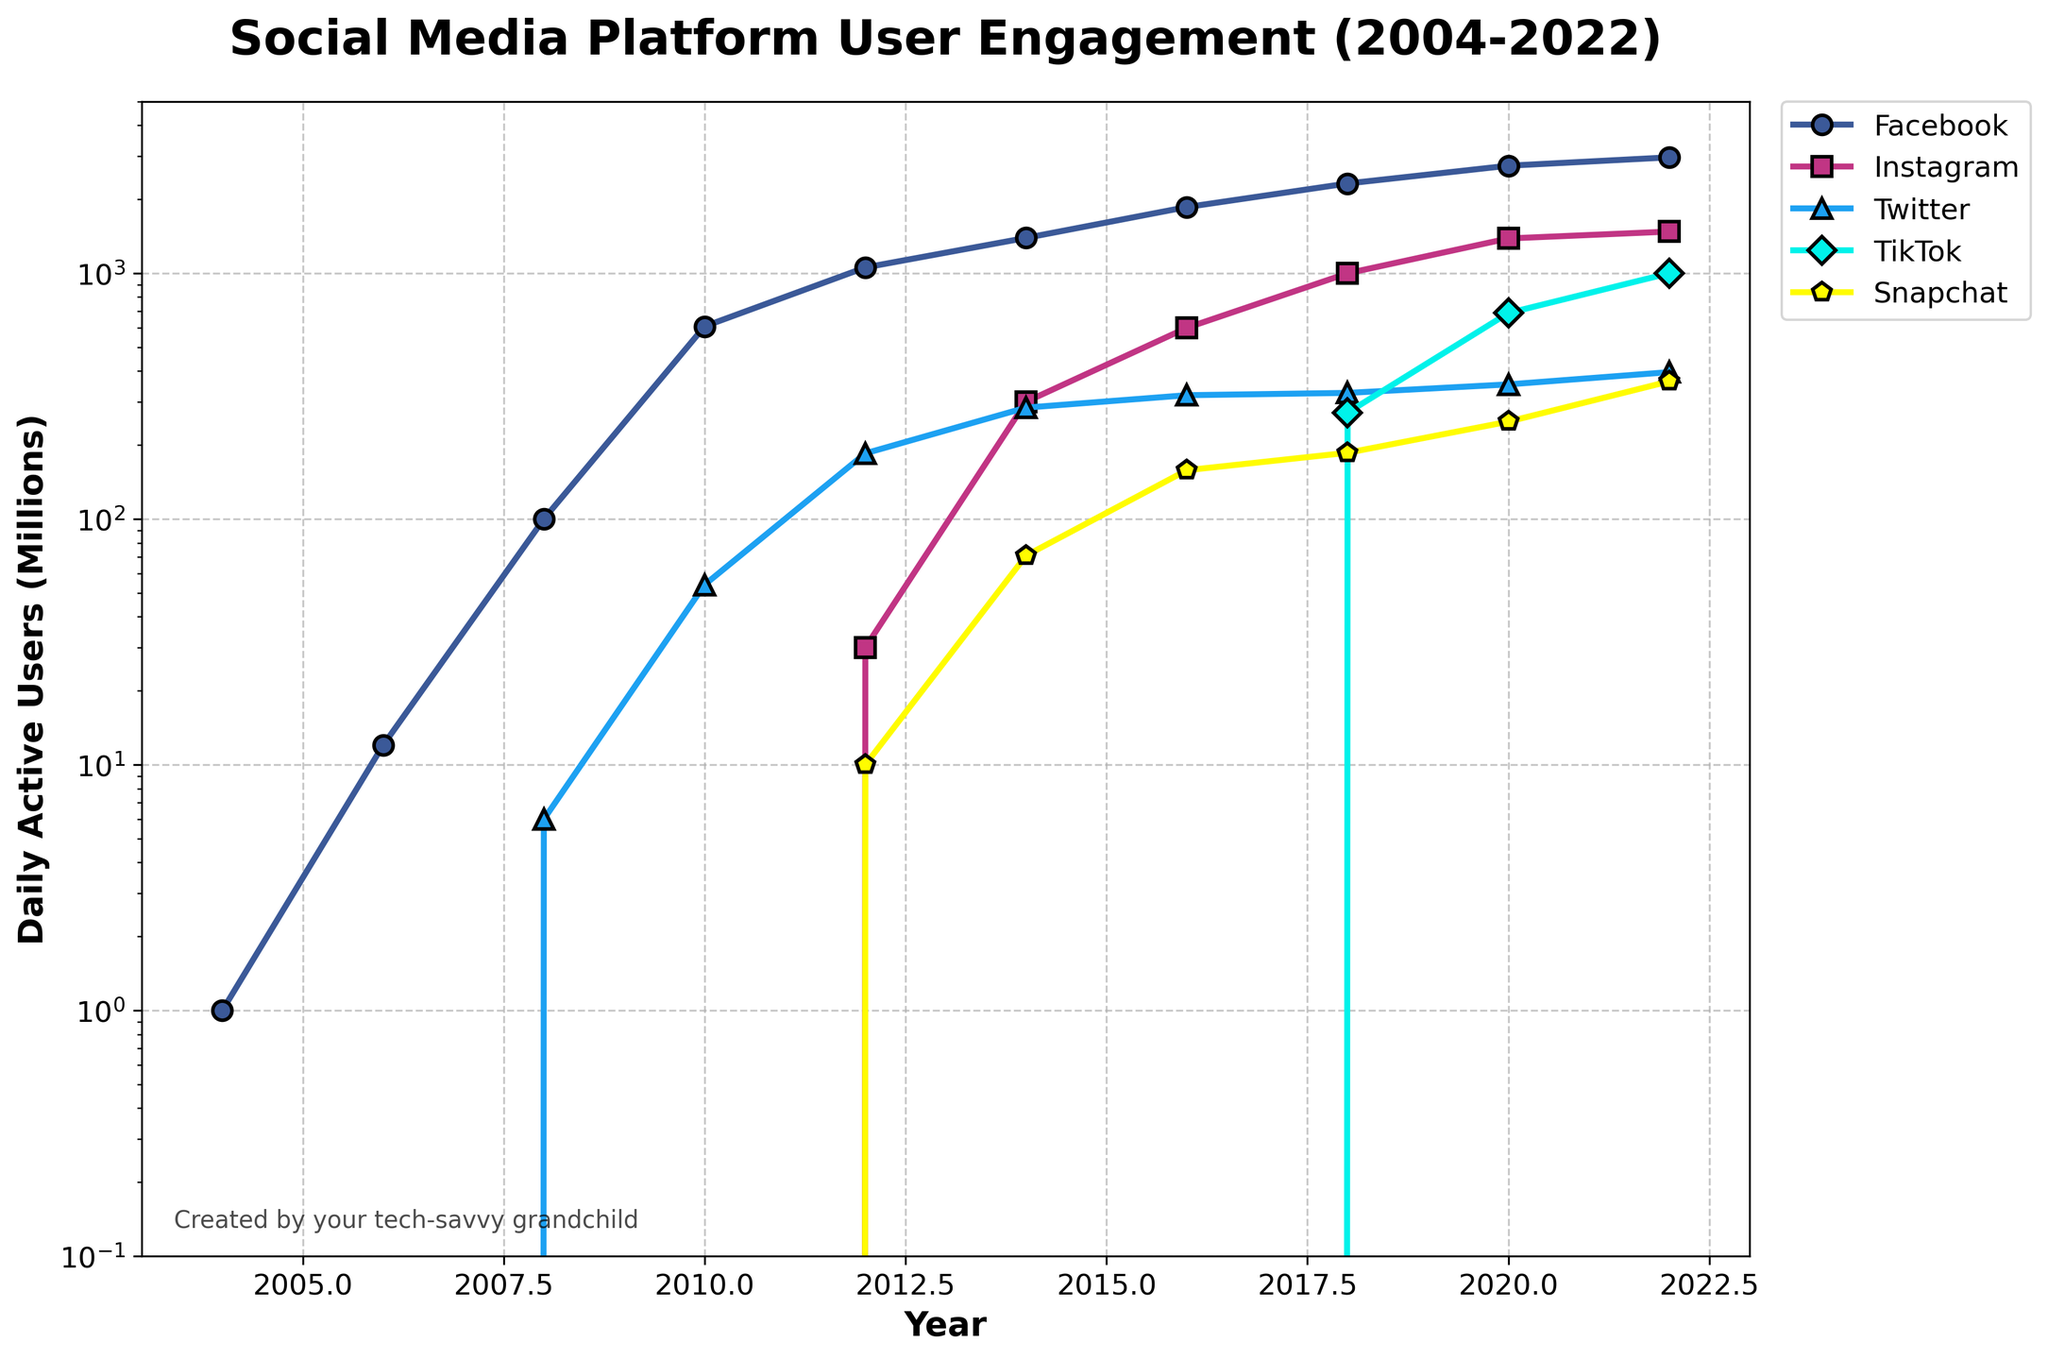What trend do you notice in Facebook's user engagement from 2004 to 2022? From 2004 to 2022, Facebook's user engagement has steadily increased, starting from 1 million daily active users in 2004 and reaching approximately 2,963 million daily active users in 2022. This shows a consistent growth in user engagement over the years.
Answer: Steady increase Which social media platform had the fastest growth in daily active users between 2018 and 2022? To identify the fastest growth, we look at the increase in daily active users for each platform between 2018 and 2022. We calculate the differences: Facebook (+643 million), Instagram (+478 million), Twitter (+70 million), TikTok (+729 million), and Snapchat (+177 million). TikTok had the fastest growth with an increase of 729 million daily active users.
Answer: TikTok In which year did Snapchat surpass 100 million daily active users? We refer to Snapchat's user engagement data over the years. In 2012, Snapchat had 10 million daily active users. By 2016, it had 158 million daily active users. Therefore, Snapchat surpassed 100 million daily active users between 2012 and 2016.
Answer: 2016 How many social media platforms had over 1 billion daily active users in 2022? Referring to the 2022 data, we note the counts for each platform: Facebook (2963 million), Instagram (1478 million), Twitter (396 million), TikTok (1000 million), and Snapchat (363 million). Both Facebook, Instagram, and TikTok had over 1 billion daily active users.
Answer: Three Which social media platform had the least growth in daily active users between 2010 and 2022? We calculate the growth for each platform between 2010 and 2022: Facebook (+2354 million), Instagram (started at 0, reaching 1478 million), Twitter (+342 million), TikTok (0 to 1000 million), and Snapchat (0 to 363 million). Twitter had the smallest increase in daily active users, growing by 342 million.
Answer: Twitter In which year did TikTok's daily active users surpass Snapchat's daily active users? By examining the user data, TikTok had 271 million users in 2018 and Snapchat 186 million. In 2020, TikTok had 689 million users, surpassing Snapchat's 249 million.
Answer: 2020 Compare the user engagements for Facebook and Instagram in 2020. In 2020, Facebook had 2740 million daily active users, while Instagram had 1386 million daily active users. Facebook's user engagement was significantly higher than Instagram’s.
Answer: Facebook higher In which year did Instagram's daily active users reach 1 billion? The growth in Instagram's users shows that it had 600 million users in 2016 and 1000 million in 2018. Hence, Instagram reached 1 billion daily active users in 2018.
Answer: 2018 Calculate the average annual growth rate of Facebook’s daily active users from 2004 to 2022. The annual growth rate is calculated by dividing the total increase in daily active users by the number of years. Total increase is 2963 million (2022 users) - 1 million (2004 users) = 2962 million. Number of years = 2022 - 2004 = 18. Average annual growth rate = 2962 / 18 ≈ 164.56 million users per year.
Answer: 164.56 million users/year Which platform had the largest user base in 2008 and what does that imply? In 2008, Facebook had 100 million users and Twitter had 6 million. Facebook had the largest user base, implying it was the most popular social media platform at that time.
Answer: Facebook 